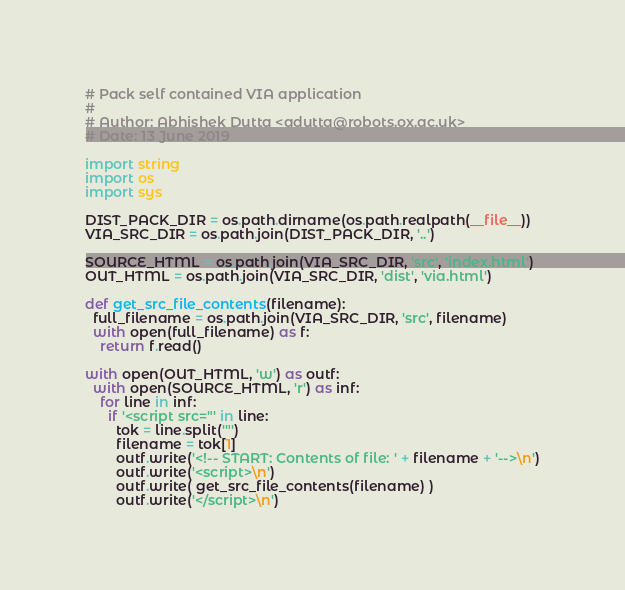Convert code to text. <code><loc_0><loc_0><loc_500><loc_500><_Python_># Pack self contained VIA application
#
# Author: Abhishek Dutta <adutta@robots.ox.ac.uk>
# Date: 13 June 2019

import string
import os
import sys

DIST_PACK_DIR = os.path.dirname(os.path.realpath(__file__))
VIA_SRC_DIR = os.path.join(DIST_PACK_DIR, '..')

SOURCE_HTML = os.path.join(VIA_SRC_DIR, 'src', 'index.html')
OUT_HTML = os.path.join(VIA_SRC_DIR, 'dist', 'via.html')

def get_src_file_contents(filename):
  full_filename = os.path.join(VIA_SRC_DIR, 'src', filename)
  with open(full_filename) as f:
    return f.read()

with open(OUT_HTML, 'w') as outf:
  with open(SOURCE_HTML, 'r') as inf:
    for line in inf:
      if '<script src="' in line:
        tok = line.split('"')
        filename = tok[1]
        outf.write('<!-- START: Contents of file: ' + filename + '-->\n')
        outf.write('<script>\n')
        outf.write( get_src_file_contents(filename) )
        outf.write('</script>\n')</code> 